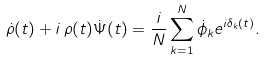<formula> <loc_0><loc_0><loc_500><loc_500>\dot { \rho } ( t ) + i \, \rho ( t ) \dot { \Psi } ( t ) = \frac { i } { N } \sum _ { k = 1 } ^ { N } \dot { \phi } _ { k } e ^ { i \delta _ { k } ( t ) } .</formula> 